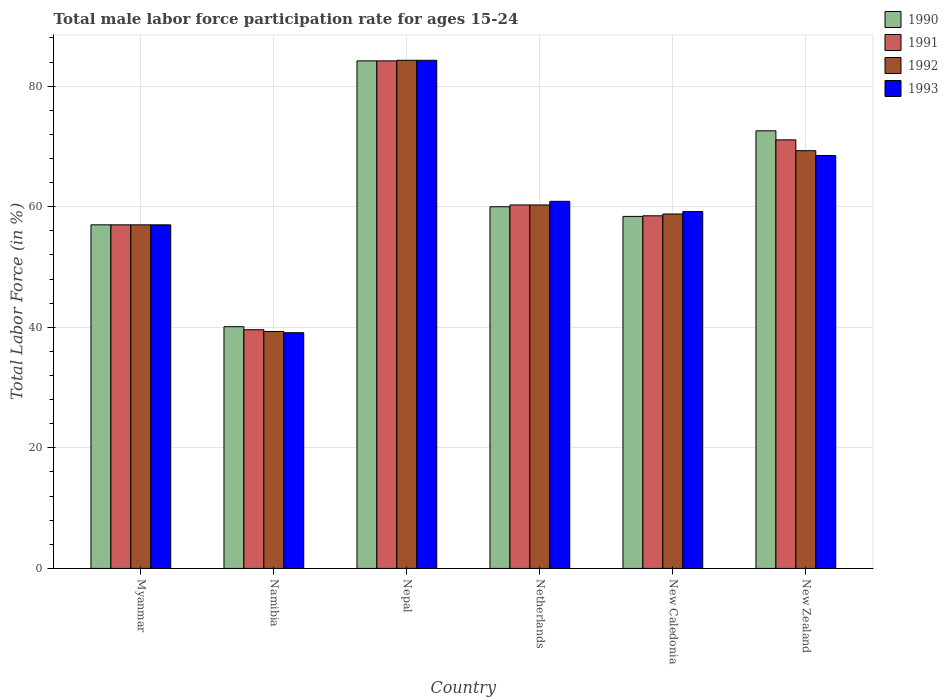How many different coloured bars are there?
Provide a succinct answer. 4. How many groups of bars are there?
Your response must be concise. 6. How many bars are there on the 6th tick from the left?
Give a very brief answer. 4. How many bars are there on the 5th tick from the right?
Give a very brief answer. 4. What is the label of the 6th group of bars from the left?
Offer a terse response. New Zealand. What is the male labor force participation rate in 1992 in Netherlands?
Your answer should be very brief. 60.3. Across all countries, what is the maximum male labor force participation rate in 1990?
Provide a short and direct response. 84.2. Across all countries, what is the minimum male labor force participation rate in 1992?
Make the answer very short. 39.3. In which country was the male labor force participation rate in 1992 maximum?
Make the answer very short. Nepal. In which country was the male labor force participation rate in 1993 minimum?
Ensure brevity in your answer.  Namibia. What is the total male labor force participation rate in 1992 in the graph?
Offer a terse response. 369. What is the difference between the male labor force participation rate in 1993 in Nepal and that in New Caledonia?
Your answer should be compact. 25.1. What is the difference between the male labor force participation rate in 1991 in New Zealand and the male labor force participation rate in 1992 in Nepal?
Ensure brevity in your answer.  -13.2. What is the average male labor force participation rate in 1991 per country?
Provide a succinct answer. 61.78. What is the ratio of the male labor force participation rate in 1991 in Netherlands to that in New Caledonia?
Provide a succinct answer. 1.03. Is the male labor force participation rate in 1990 in Netherlands less than that in New Caledonia?
Provide a short and direct response. No. What is the difference between the highest and the lowest male labor force participation rate in 1990?
Your answer should be compact. 44.1. In how many countries, is the male labor force participation rate in 1992 greater than the average male labor force participation rate in 1992 taken over all countries?
Give a very brief answer. 2. Is it the case that in every country, the sum of the male labor force participation rate in 1991 and male labor force participation rate in 1990 is greater than the sum of male labor force participation rate in 1992 and male labor force participation rate in 1993?
Ensure brevity in your answer.  No. What does the 4th bar from the left in Netherlands represents?
Provide a succinct answer. 1993. Is it the case that in every country, the sum of the male labor force participation rate in 1992 and male labor force participation rate in 1993 is greater than the male labor force participation rate in 1991?
Offer a terse response. Yes. How many bars are there?
Your response must be concise. 24. Are all the bars in the graph horizontal?
Your answer should be compact. No. What is the difference between two consecutive major ticks on the Y-axis?
Provide a succinct answer. 20. Where does the legend appear in the graph?
Your response must be concise. Top right. How many legend labels are there?
Make the answer very short. 4. What is the title of the graph?
Offer a very short reply. Total male labor force participation rate for ages 15-24. What is the label or title of the X-axis?
Keep it short and to the point. Country. What is the label or title of the Y-axis?
Offer a very short reply. Total Labor Force (in %). What is the Total Labor Force (in %) in 1991 in Myanmar?
Provide a short and direct response. 57. What is the Total Labor Force (in %) in 1992 in Myanmar?
Your response must be concise. 57. What is the Total Labor Force (in %) of 1990 in Namibia?
Provide a succinct answer. 40.1. What is the Total Labor Force (in %) in 1991 in Namibia?
Give a very brief answer. 39.6. What is the Total Labor Force (in %) in 1992 in Namibia?
Provide a short and direct response. 39.3. What is the Total Labor Force (in %) of 1993 in Namibia?
Provide a short and direct response. 39.1. What is the Total Labor Force (in %) in 1990 in Nepal?
Provide a short and direct response. 84.2. What is the Total Labor Force (in %) in 1991 in Nepal?
Offer a very short reply. 84.2. What is the Total Labor Force (in %) of 1992 in Nepal?
Offer a very short reply. 84.3. What is the Total Labor Force (in %) of 1993 in Nepal?
Offer a terse response. 84.3. What is the Total Labor Force (in %) of 1990 in Netherlands?
Offer a very short reply. 60. What is the Total Labor Force (in %) of 1991 in Netherlands?
Offer a very short reply. 60.3. What is the Total Labor Force (in %) in 1992 in Netherlands?
Your response must be concise. 60.3. What is the Total Labor Force (in %) in 1993 in Netherlands?
Provide a succinct answer. 60.9. What is the Total Labor Force (in %) in 1990 in New Caledonia?
Give a very brief answer. 58.4. What is the Total Labor Force (in %) of 1991 in New Caledonia?
Offer a terse response. 58.5. What is the Total Labor Force (in %) of 1992 in New Caledonia?
Your answer should be very brief. 58.8. What is the Total Labor Force (in %) in 1993 in New Caledonia?
Offer a terse response. 59.2. What is the Total Labor Force (in %) in 1990 in New Zealand?
Provide a short and direct response. 72.6. What is the Total Labor Force (in %) in 1991 in New Zealand?
Your answer should be compact. 71.1. What is the Total Labor Force (in %) in 1992 in New Zealand?
Keep it short and to the point. 69.3. What is the Total Labor Force (in %) of 1993 in New Zealand?
Provide a short and direct response. 68.5. Across all countries, what is the maximum Total Labor Force (in %) of 1990?
Offer a terse response. 84.2. Across all countries, what is the maximum Total Labor Force (in %) in 1991?
Give a very brief answer. 84.2. Across all countries, what is the maximum Total Labor Force (in %) of 1992?
Give a very brief answer. 84.3. Across all countries, what is the maximum Total Labor Force (in %) of 1993?
Provide a short and direct response. 84.3. Across all countries, what is the minimum Total Labor Force (in %) of 1990?
Offer a terse response. 40.1. Across all countries, what is the minimum Total Labor Force (in %) in 1991?
Offer a very short reply. 39.6. Across all countries, what is the minimum Total Labor Force (in %) of 1992?
Keep it short and to the point. 39.3. Across all countries, what is the minimum Total Labor Force (in %) of 1993?
Your response must be concise. 39.1. What is the total Total Labor Force (in %) in 1990 in the graph?
Provide a short and direct response. 372.3. What is the total Total Labor Force (in %) of 1991 in the graph?
Ensure brevity in your answer.  370.7. What is the total Total Labor Force (in %) of 1992 in the graph?
Offer a terse response. 369. What is the total Total Labor Force (in %) in 1993 in the graph?
Provide a succinct answer. 369. What is the difference between the Total Labor Force (in %) in 1990 in Myanmar and that in Namibia?
Make the answer very short. 16.9. What is the difference between the Total Labor Force (in %) of 1992 in Myanmar and that in Namibia?
Provide a succinct answer. 17.7. What is the difference between the Total Labor Force (in %) in 1993 in Myanmar and that in Namibia?
Give a very brief answer. 17.9. What is the difference between the Total Labor Force (in %) in 1990 in Myanmar and that in Nepal?
Keep it short and to the point. -27.2. What is the difference between the Total Labor Force (in %) in 1991 in Myanmar and that in Nepal?
Provide a short and direct response. -27.2. What is the difference between the Total Labor Force (in %) of 1992 in Myanmar and that in Nepal?
Ensure brevity in your answer.  -27.3. What is the difference between the Total Labor Force (in %) in 1993 in Myanmar and that in Nepal?
Your answer should be very brief. -27.3. What is the difference between the Total Labor Force (in %) of 1990 in Myanmar and that in Netherlands?
Your response must be concise. -3. What is the difference between the Total Labor Force (in %) of 1991 in Myanmar and that in Netherlands?
Your response must be concise. -3.3. What is the difference between the Total Labor Force (in %) in 1992 in Myanmar and that in Netherlands?
Ensure brevity in your answer.  -3.3. What is the difference between the Total Labor Force (in %) of 1993 in Myanmar and that in Netherlands?
Your response must be concise. -3.9. What is the difference between the Total Labor Force (in %) of 1990 in Myanmar and that in New Zealand?
Ensure brevity in your answer.  -15.6. What is the difference between the Total Labor Force (in %) of 1991 in Myanmar and that in New Zealand?
Your answer should be very brief. -14.1. What is the difference between the Total Labor Force (in %) in 1992 in Myanmar and that in New Zealand?
Offer a very short reply. -12.3. What is the difference between the Total Labor Force (in %) of 1993 in Myanmar and that in New Zealand?
Ensure brevity in your answer.  -11.5. What is the difference between the Total Labor Force (in %) in 1990 in Namibia and that in Nepal?
Give a very brief answer. -44.1. What is the difference between the Total Labor Force (in %) in 1991 in Namibia and that in Nepal?
Make the answer very short. -44.6. What is the difference between the Total Labor Force (in %) in 1992 in Namibia and that in Nepal?
Make the answer very short. -45. What is the difference between the Total Labor Force (in %) in 1993 in Namibia and that in Nepal?
Offer a very short reply. -45.2. What is the difference between the Total Labor Force (in %) of 1990 in Namibia and that in Netherlands?
Make the answer very short. -19.9. What is the difference between the Total Labor Force (in %) in 1991 in Namibia and that in Netherlands?
Make the answer very short. -20.7. What is the difference between the Total Labor Force (in %) of 1993 in Namibia and that in Netherlands?
Your response must be concise. -21.8. What is the difference between the Total Labor Force (in %) of 1990 in Namibia and that in New Caledonia?
Offer a very short reply. -18.3. What is the difference between the Total Labor Force (in %) in 1991 in Namibia and that in New Caledonia?
Ensure brevity in your answer.  -18.9. What is the difference between the Total Labor Force (in %) in 1992 in Namibia and that in New Caledonia?
Give a very brief answer. -19.5. What is the difference between the Total Labor Force (in %) of 1993 in Namibia and that in New Caledonia?
Ensure brevity in your answer.  -20.1. What is the difference between the Total Labor Force (in %) of 1990 in Namibia and that in New Zealand?
Provide a succinct answer. -32.5. What is the difference between the Total Labor Force (in %) of 1991 in Namibia and that in New Zealand?
Provide a short and direct response. -31.5. What is the difference between the Total Labor Force (in %) in 1993 in Namibia and that in New Zealand?
Your answer should be compact. -29.4. What is the difference between the Total Labor Force (in %) in 1990 in Nepal and that in Netherlands?
Your response must be concise. 24.2. What is the difference between the Total Labor Force (in %) of 1991 in Nepal and that in Netherlands?
Your answer should be compact. 23.9. What is the difference between the Total Labor Force (in %) of 1992 in Nepal and that in Netherlands?
Provide a short and direct response. 24. What is the difference between the Total Labor Force (in %) in 1993 in Nepal and that in Netherlands?
Make the answer very short. 23.4. What is the difference between the Total Labor Force (in %) in 1990 in Nepal and that in New Caledonia?
Offer a very short reply. 25.8. What is the difference between the Total Labor Force (in %) of 1991 in Nepal and that in New Caledonia?
Offer a very short reply. 25.7. What is the difference between the Total Labor Force (in %) of 1993 in Nepal and that in New Caledonia?
Ensure brevity in your answer.  25.1. What is the difference between the Total Labor Force (in %) in 1992 in Nepal and that in New Zealand?
Ensure brevity in your answer.  15. What is the difference between the Total Labor Force (in %) in 1993 in Nepal and that in New Zealand?
Give a very brief answer. 15.8. What is the difference between the Total Labor Force (in %) of 1992 in Netherlands and that in New Caledonia?
Offer a terse response. 1.5. What is the difference between the Total Labor Force (in %) of 1990 in Netherlands and that in New Zealand?
Your answer should be compact. -12.6. What is the difference between the Total Labor Force (in %) in 1991 in Netherlands and that in New Zealand?
Your answer should be very brief. -10.8. What is the difference between the Total Labor Force (in %) of 1990 in New Caledonia and that in New Zealand?
Give a very brief answer. -14.2. What is the difference between the Total Labor Force (in %) in 1991 in New Caledonia and that in New Zealand?
Keep it short and to the point. -12.6. What is the difference between the Total Labor Force (in %) of 1992 in New Caledonia and that in New Zealand?
Provide a succinct answer. -10.5. What is the difference between the Total Labor Force (in %) in 1993 in New Caledonia and that in New Zealand?
Give a very brief answer. -9.3. What is the difference between the Total Labor Force (in %) in 1990 in Myanmar and the Total Labor Force (in %) in 1991 in Namibia?
Your response must be concise. 17.4. What is the difference between the Total Labor Force (in %) in 1990 in Myanmar and the Total Labor Force (in %) in 1993 in Namibia?
Provide a succinct answer. 17.9. What is the difference between the Total Labor Force (in %) of 1991 in Myanmar and the Total Labor Force (in %) of 1993 in Namibia?
Provide a short and direct response. 17.9. What is the difference between the Total Labor Force (in %) in 1990 in Myanmar and the Total Labor Force (in %) in 1991 in Nepal?
Give a very brief answer. -27.2. What is the difference between the Total Labor Force (in %) of 1990 in Myanmar and the Total Labor Force (in %) of 1992 in Nepal?
Make the answer very short. -27.3. What is the difference between the Total Labor Force (in %) in 1990 in Myanmar and the Total Labor Force (in %) in 1993 in Nepal?
Offer a terse response. -27.3. What is the difference between the Total Labor Force (in %) of 1991 in Myanmar and the Total Labor Force (in %) of 1992 in Nepal?
Make the answer very short. -27.3. What is the difference between the Total Labor Force (in %) of 1991 in Myanmar and the Total Labor Force (in %) of 1993 in Nepal?
Give a very brief answer. -27.3. What is the difference between the Total Labor Force (in %) of 1992 in Myanmar and the Total Labor Force (in %) of 1993 in Nepal?
Make the answer very short. -27.3. What is the difference between the Total Labor Force (in %) in 1990 in Myanmar and the Total Labor Force (in %) in 1992 in Netherlands?
Your answer should be very brief. -3.3. What is the difference between the Total Labor Force (in %) of 1990 in Myanmar and the Total Labor Force (in %) of 1991 in New Zealand?
Provide a succinct answer. -14.1. What is the difference between the Total Labor Force (in %) of 1991 in Myanmar and the Total Labor Force (in %) of 1992 in New Zealand?
Offer a very short reply. -12.3. What is the difference between the Total Labor Force (in %) of 1992 in Myanmar and the Total Labor Force (in %) of 1993 in New Zealand?
Offer a terse response. -11.5. What is the difference between the Total Labor Force (in %) in 1990 in Namibia and the Total Labor Force (in %) in 1991 in Nepal?
Offer a terse response. -44.1. What is the difference between the Total Labor Force (in %) in 1990 in Namibia and the Total Labor Force (in %) in 1992 in Nepal?
Your answer should be very brief. -44.2. What is the difference between the Total Labor Force (in %) of 1990 in Namibia and the Total Labor Force (in %) of 1993 in Nepal?
Offer a very short reply. -44.2. What is the difference between the Total Labor Force (in %) of 1991 in Namibia and the Total Labor Force (in %) of 1992 in Nepal?
Your response must be concise. -44.7. What is the difference between the Total Labor Force (in %) of 1991 in Namibia and the Total Labor Force (in %) of 1993 in Nepal?
Offer a very short reply. -44.7. What is the difference between the Total Labor Force (in %) in 1992 in Namibia and the Total Labor Force (in %) in 1993 in Nepal?
Provide a succinct answer. -45. What is the difference between the Total Labor Force (in %) in 1990 in Namibia and the Total Labor Force (in %) in 1991 in Netherlands?
Keep it short and to the point. -20.2. What is the difference between the Total Labor Force (in %) in 1990 in Namibia and the Total Labor Force (in %) in 1992 in Netherlands?
Provide a succinct answer. -20.2. What is the difference between the Total Labor Force (in %) in 1990 in Namibia and the Total Labor Force (in %) in 1993 in Netherlands?
Provide a succinct answer. -20.8. What is the difference between the Total Labor Force (in %) in 1991 in Namibia and the Total Labor Force (in %) in 1992 in Netherlands?
Your response must be concise. -20.7. What is the difference between the Total Labor Force (in %) of 1991 in Namibia and the Total Labor Force (in %) of 1993 in Netherlands?
Provide a succinct answer. -21.3. What is the difference between the Total Labor Force (in %) in 1992 in Namibia and the Total Labor Force (in %) in 1993 in Netherlands?
Offer a terse response. -21.6. What is the difference between the Total Labor Force (in %) in 1990 in Namibia and the Total Labor Force (in %) in 1991 in New Caledonia?
Your answer should be very brief. -18.4. What is the difference between the Total Labor Force (in %) of 1990 in Namibia and the Total Labor Force (in %) of 1992 in New Caledonia?
Ensure brevity in your answer.  -18.7. What is the difference between the Total Labor Force (in %) of 1990 in Namibia and the Total Labor Force (in %) of 1993 in New Caledonia?
Provide a succinct answer. -19.1. What is the difference between the Total Labor Force (in %) of 1991 in Namibia and the Total Labor Force (in %) of 1992 in New Caledonia?
Ensure brevity in your answer.  -19.2. What is the difference between the Total Labor Force (in %) of 1991 in Namibia and the Total Labor Force (in %) of 1993 in New Caledonia?
Your response must be concise. -19.6. What is the difference between the Total Labor Force (in %) in 1992 in Namibia and the Total Labor Force (in %) in 1993 in New Caledonia?
Provide a succinct answer. -19.9. What is the difference between the Total Labor Force (in %) in 1990 in Namibia and the Total Labor Force (in %) in 1991 in New Zealand?
Your response must be concise. -31. What is the difference between the Total Labor Force (in %) of 1990 in Namibia and the Total Labor Force (in %) of 1992 in New Zealand?
Provide a short and direct response. -29.2. What is the difference between the Total Labor Force (in %) in 1990 in Namibia and the Total Labor Force (in %) in 1993 in New Zealand?
Offer a very short reply. -28.4. What is the difference between the Total Labor Force (in %) of 1991 in Namibia and the Total Labor Force (in %) of 1992 in New Zealand?
Keep it short and to the point. -29.7. What is the difference between the Total Labor Force (in %) of 1991 in Namibia and the Total Labor Force (in %) of 1993 in New Zealand?
Your answer should be compact. -28.9. What is the difference between the Total Labor Force (in %) of 1992 in Namibia and the Total Labor Force (in %) of 1993 in New Zealand?
Offer a very short reply. -29.2. What is the difference between the Total Labor Force (in %) in 1990 in Nepal and the Total Labor Force (in %) in 1991 in Netherlands?
Your answer should be compact. 23.9. What is the difference between the Total Labor Force (in %) in 1990 in Nepal and the Total Labor Force (in %) in 1992 in Netherlands?
Offer a very short reply. 23.9. What is the difference between the Total Labor Force (in %) of 1990 in Nepal and the Total Labor Force (in %) of 1993 in Netherlands?
Keep it short and to the point. 23.3. What is the difference between the Total Labor Force (in %) in 1991 in Nepal and the Total Labor Force (in %) in 1992 in Netherlands?
Your answer should be compact. 23.9. What is the difference between the Total Labor Force (in %) of 1991 in Nepal and the Total Labor Force (in %) of 1993 in Netherlands?
Provide a succinct answer. 23.3. What is the difference between the Total Labor Force (in %) in 1992 in Nepal and the Total Labor Force (in %) in 1993 in Netherlands?
Offer a very short reply. 23.4. What is the difference between the Total Labor Force (in %) of 1990 in Nepal and the Total Labor Force (in %) of 1991 in New Caledonia?
Offer a very short reply. 25.7. What is the difference between the Total Labor Force (in %) in 1990 in Nepal and the Total Labor Force (in %) in 1992 in New Caledonia?
Your answer should be very brief. 25.4. What is the difference between the Total Labor Force (in %) of 1990 in Nepal and the Total Labor Force (in %) of 1993 in New Caledonia?
Provide a short and direct response. 25. What is the difference between the Total Labor Force (in %) in 1991 in Nepal and the Total Labor Force (in %) in 1992 in New Caledonia?
Your response must be concise. 25.4. What is the difference between the Total Labor Force (in %) of 1992 in Nepal and the Total Labor Force (in %) of 1993 in New Caledonia?
Your answer should be compact. 25.1. What is the difference between the Total Labor Force (in %) in 1990 in Nepal and the Total Labor Force (in %) in 1992 in New Zealand?
Your answer should be very brief. 14.9. What is the difference between the Total Labor Force (in %) in 1991 in Nepal and the Total Labor Force (in %) in 1992 in New Zealand?
Ensure brevity in your answer.  14.9. What is the difference between the Total Labor Force (in %) of 1992 in Nepal and the Total Labor Force (in %) of 1993 in New Zealand?
Keep it short and to the point. 15.8. What is the difference between the Total Labor Force (in %) of 1990 in Netherlands and the Total Labor Force (in %) of 1992 in New Caledonia?
Ensure brevity in your answer.  1.2. What is the difference between the Total Labor Force (in %) of 1991 in Netherlands and the Total Labor Force (in %) of 1992 in New Caledonia?
Ensure brevity in your answer.  1.5. What is the difference between the Total Labor Force (in %) in 1992 in Netherlands and the Total Labor Force (in %) in 1993 in New Caledonia?
Provide a short and direct response. 1.1. What is the difference between the Total Labor Force (in %) in 1990 in Netherlands and the Total Labor Force (in %) in 1992 in New Zealand?
Your answer should be very brief. -9.3. What is the difference between the Total Labor Force (in %) in 1991 in Netherlands and the Total Labor Force (in %) in 1992 in New Zealand?
Your response must be concise. -9. What is the difference between the Total Labor Force (in %) in 1991 in New Caledonia and the Total Labor Force (in %) in 1993 in New Zealand?
Your answer should be very brief. -10. What is the difference between the Total Labor Force (in %) of 1992 in New Caledonia and the Total Labor Force (in %) of 1993 in New Zealand?
Offer a terse response. -9.7. What is the average Total Labor Force (in %) in 1990 per country?
Your answer should be very brief. 62.05. What is the average Total Labor Force (in %) in 1991 per country?
Make the answer very short. 61.78. What is the average Total Labor Force (in %) of 1992 per country?
Ensure brevity in your answer.  61.5. What is the average Total Labor Force (in %) of 1993 per country?
Provide a succinct answer. 61.5. What is the difference between the Total Labor Force (in %) of 1990 and Total Labor Force (in %) of 1992 in Myanmar?
Offer a terse response. 0. What is the difference between the Total Labor Force (in %) in 1990 and Total Labor Force (in %) in 1993 in Myanmar?
Provide a succinct answer. 0. What is the difference between the Total Labor Force (in %) of 1990 and Total Labor Force (in %) of 1991 in Namibia?
Provide a succinct answer. 0.5. What is the difference between the Total Labor Force (in %) in 1990 and Total Labor Force (in %) in 1992 in Namibia?
Offer a terse response. 0.8. What is the difference between the Total Labor Force (in %) of 1991 and Total Labor Force (in %) of 1993 in Namibia?
Offer a very short reply. 0.5. What is the difference between the Total Labor Force (in %) in 1992 and Total Labor Force (in %) in 1993 in Namibia?
Ensure brevity in your answer.  0.2. What is the difference between the Total Labor Force (in %) of 1990 and Total Labor Force (in %) of 1993 in Nepal?
Your response must be concise. -0.1. What is the difference between the Total Labor Force (in %) of 1992 and Total Labor Force (in %) of 1993 in Nepal?
Make the answer very short. 0. What is the difference between the Total Labor Force (in %) of 1990 and Total Labor Force (in %) of 1992 in Netherlands?
Give a very brief answer. -0.3. What is the difference between the Total Labor Force (in %) in 1990 and Total Labor Force (in %) in 1993 in Netherlands?
Make the answer very short. -0.9. What is the difference between the Total Labor Force (in %) of 1991 and Total Labor Force (in %) of 1992 in Netherlands?
Keep it short and to the point. 0. What is the difference between the Total Labor Force (in %) of 1991 and Total Labor Force (in %) of 1993 in Netherlands?
Offer a very short reply. -0.6. What is the difference between the Total Labor Force (in %) of 1990 and Total Labor Force (in %) of 1993 in New Caledonia?
Give a very brief answer. -0.8. What is the difference between the Total Labor Force (in %) of 1991 and Total Labor Force (in %) of 1992 in New Caledonia?
Provide a succinct answer. -0.3. What is the difference between the Total Labor Force (in %) in 1991 and Total Labor Force (in %) in 1993 in New Caledonia?
Offer a terse response. -0.7. What is the difference between the Total Labor Force (in %) in 1992 and Total Labor Force (in %) in 1993 in New Caledonia?
Ensure brevity in your answer.  -0.4. What is the difference between the Total Labor Force (in %) in 1990 and Total Labor Force (in %) in 1991 in New Zealand?
Your response must be concise. 1.5. What is the difference between the Total Labor Force (in %) of 1990 and Total Labor Force (in %) of 1992 in New Zealand?
Give a very brief answer. 3.3. What is the difference between the Total Labor Force (in %) of 1990 and Total Labor Force (in %) of 1993 in New Zealand?
Ensure brevity in your answer.  4.1. What is the difference between the Total Labor Force (in %) of 1991 and Total Labor Force (in %) of 1992 in New Zealand?
Provide a short and direct response. 1.8. What is the ratio of the Total Labor Force (in %) in 1990 in Myanmar to that in Namibia?
Ensure brevity in your answer.  1.42. What is the ratio of the Total Labor Force (in %) of 1991 in Myanmar to that in Namibia?
Your answer should be compact. 1.44. What is the ratio of the Total Labor Force (in %) in 1992 in Myanmar to that in Namibia?
Ensure brevity in your answer.  1.45. What is the ratio of the Total Labor Force (in %) of 1993 in Myanmar to that in Namibia?
Provide a succinct answer. 1.46. What is the ratio of the Total Labor Force (in %) of 1990 in Myanmar to that in Nepal?
Keep it short and to the point. 0.68. What is the ratio of the Total Labor Force (in %) in 1991 in Myanmar to that in Nepal?
Keep it short and to the point. 0.68. What is the ratio of the Total Labor Force (in %) of 1992 in Myanmar to that in Nepal?
Provide a short and direct response. 0.68. What is the ratio of the Total Labor Force (in %) of 1993 in Myanmar to that in Nepal?
Ensure brevity in your answer.  0.68. What is the ratio of the Total Labor Force (in %) of 1990 in Myanmar to that in Netherlands?
Offer a very short reply. 0.95. What is the ratio of the Total Labor Force (in %) in 1991 in Myanmar to that in Netherlands?
Your answer should be compact. 0.95. What is the ratio of the Total Labor Force (in %) in 1992 in Myanmar to that in Netherlands?
Keep it short and to the point. 0.95. What is the ratio of the Total Labor Force (in %) of 1993 in Myanmar to that in Netherlands?
Provide a succinct answer. 0.94. What is the ratio of the Total Labor Force (in %) in 1990 in Myanmar to that in New Caledonia?
Make the answer very short. 0.98. What is the ratio of the Total Labor Force (in %) in 1991 in Myanmar to that in New Caledonia?
Offer a terse response. 0.97. What is the ratio of the Total Labor Force (in %) in 1992 in Myanmar to that in New Caledonia?
Offer a very short reply. 0.97. What is the ratio of the Total Labor Force (in %) in 1993 in Myanmar to that in New Caledonia?
Your response must be concise. 0.96. What is the ratio of the Total Labor Force (in %) in 1990 in Myanmar to that in New Zealand?
Keep it short and to the point. 0.79. What is the ratio of the Total Labor Force (in %) in 1991 in Myanmar to that in New Zealand?
Make the answer very short. 0.8. What is the ratio of the Total Labor Force (in %) in 1992 in Myanmar to that in New Zealand?
Your answer should be very brief. 0.82. What is the ratio of the Total Labor Force (in %) in 1993 in Myanmar to that in New Zealand?
Make the answer very short. 0.83. What is the ratio of the Total Labor Force (in %) in 1990 in Namibia to that in Nepal?
Provide a succinct answer. 0.48. What is the ratio of the Total Labor Force (in %) in 1991 in Namibia to that in Nepal?
Keep it short and to the point. 0.47. What is the ratio of the Total Labor Force (in %) in 1992 in Namibia to that in Nepal?
Your answer should be very brief. 0.47. What is the ratio of the Total Labor Force (in %) of 1993 in Namibia to that in Nepal?
Your answer should be compact. 0.46. What is the ratio of the Total Labor Force (in %) of 1990 in Namibia to that in Netherlands?
Offer a terse response. 0.67. What is the ratio of the Total Labor Force (in %) in 1991 in Namibia to that in Netherlands?
Keep it short and to the point. 0.66. What is the ratio of the Total Labor Force (in %) in 1992 in Namibia to that in Netherlands?
Keep it short and to the point. 0.65. What is the ratio of the Total Labor Force (in %) of 1993 in Namibia to that in Netherlands?
Your answer should be very brief. 0.64. What is the ratio of the Total Labor Force (in %) in 1990 in Namibia to that in New Caledonia?
Provide a short and direct response. 0.69. What is the ratio of the Total Labor Force (in %) in 1991 in Namibia to that in New Caledonia?
Provide a short and direct response. 0.68. What is the ratio of the Total Labor Force (in %) in 1992 in Namibia to that in New Caledonia?
Your answer should be very brief. 0.67. What is the ratio of the Total Labor Force (in %) of 1993 in Namibia to that in New Caledonia?
Your response must be concise. 0.66. What is the ratio of the Total Labor Force (in %) in 1990 in Namibia to that in New Zealand?
Give a very brief answer. 0.55. What is the ratio of the Total Labor Force (in %) in 1991 in Namibia to that in New Zealand?
Offer a terse response. 0.56. What is the ratio of the Total Labor Force (in %) in 1992 in Namibia to that in New Zealand?
Offer a very short reply. 0.57. What is the ratio of the Total Labor Force (in %) of 1993 in Namibia to that in New Zealand?
Provide a short and direct response. 0.57. What is the ratio of the Total Labor Force (in %) of 1990 in Nepal to that in Netherlands?
Provide a short and direct response. 1.4. What is the ratio of the Total Labor Force (in %) in 1991 in Nepal to that in Netherlands?
Give a very brief answer. 1.4. What is the ratio of the Total Labor Force (in %) of 1992 in Nepal to that in Netherlands?
Offer a very short reply. 1.4. What is the ratio of the Total Labor Force (in %) in 1993 in Nepal to that in Netherlands?
Provide a short and direct response. 1.38. What is the ratio of the Total Labor Force (in %) in 1990 in Nepal to that in New Caledonia?
Offer a very short reply. 1.44. What is the ratio of the Total Labor Force (in %) of 1991 in Nepal to that in New Caledonia?
Your answer should be compact. 1.44. What is the ratio of the Total Labor Force (in %) in 1992 in Nepal to that in New Caledonia?
Your answer should be compact. 1.43. What is the ratio of the Total Labor Force (in %) of 1993 in Nepal to that in New Caledonia?
Keep it short and to the point. 1.42. What is the ratio of the Total Labor Force (in %) of 1990 in Nepal to that in New Zealand?
Offer a terse response. 1.16. What is the ratio of the Total Labor Force (in %) of 1991 in Nepal to that in New Zealand?
Your answer should be compact. 1.18. What is the ratio of the Total Labor Force (in %) in 1992 in Nepal to that in New Zealand?
Your answer should be very brief. 1.22. What is the ratio of the Total Labor Force (in %) of 1993 in Nepal to that in New Zealand?
Give a very brief answer. 1.23. What is the ratio of the Total Labor Force (in %) in 1990 in Netherlands to that in New Caledonia?
Offer a terse response. 1.03. What is the ratio of the Total Labor Force (in %) of 1991 in Netherlands to that in New Caledonia?
Give a very brief answer. 1.03. What is the ratio of the Total Labor Force (in %) in 1992 in Netherlands to that in New Caledonia?
Make the answer very short. 1.03. What is the ratio of the Total Labor Force (in %) in 1993 in Netherlands to that in New Caledonia?
Offer a terse response. 1.03. What is the ratio of the Total Labor Force (in %) of 1990 in Netherlands to that in New Zealand?
Your response must be concise. 0.83. What is the ratio of the Total Labor Force (in %) in 1991 in Netherlands to that in New Zealand?
Offer a terse response. 0.85. What is the ratio of the Total Labor Force (in %) in 1992 in Netherlands to that in New Zealand?
Provide a succinct answer. 0.87. What is the ratio of the Total Labor Force (in %) in 1993 in Netherlands to that in New Zealand?
Ensure brevity in your answer.  0.89. What is the ratio of the Total Labor Force (in %) in 1990 in New Caledonia to that in New Zealand?
Provide a short and direct response. 0.8. What is the ratio of the Total Labor Force (in %) of 1991 in New Caledonia to that in New Zealand?
Make the answer very short. 0.82. What is the ratio of the Total Labor Force (in %) in 1992 in New Caledonia to that in New Zealand?
Your response must be concise. 0.85. What is the ratio of the Total Labor Force (in %) in 1993 in New Caledonia to that in New Zealand?
Your response must be concise. 0.86. What is the difference between the highest and the second highest Total Labor Force (in %) in 1993?
Give a very brief answer. 15.8. What is the difference between the highest and the lowest Total Labor Force (in %) of 1990?
Provide a short and direct response. 44.1. What is the difference between the highest and the lowest Total Labor Force (in %) in 1991?
Your answer should be very brief. 44.6. What is the difference between the highest and the lowest Total Labor Force (in %) of 1993?
Your answer should be compact. 45.2. 